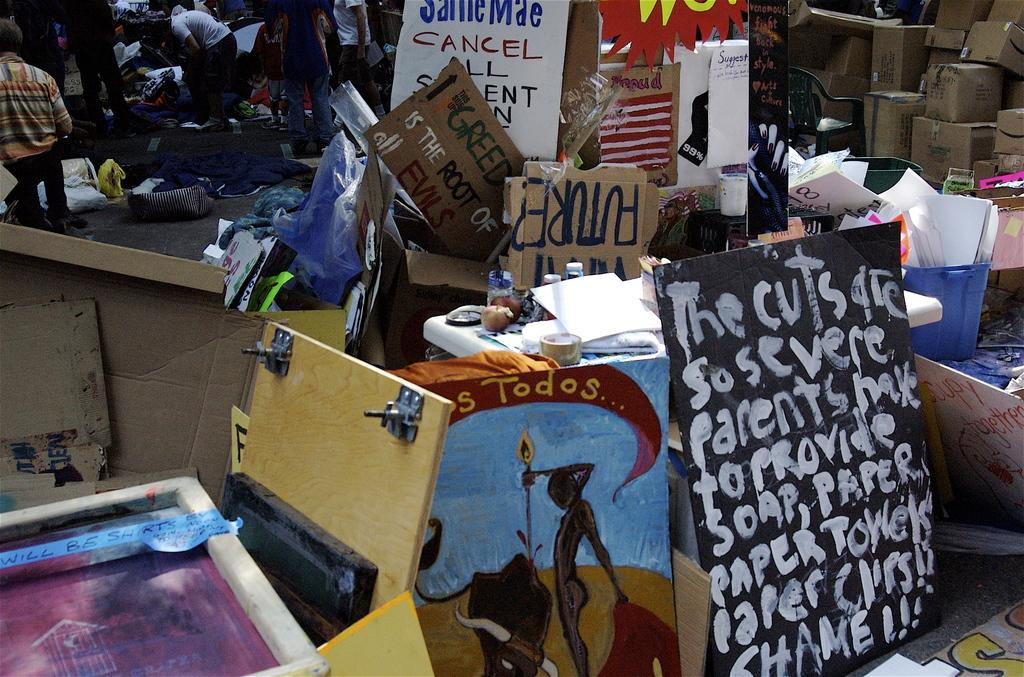Who or what can be seen in the image? There are people in the image. What objects are present in the image besides the people? There are boards, cardboard boxes, and papers visible in the image. What is covering the road in the image? There is a plastic cover on the road in the image. What can be inferred about the colors of the objects in the image? The objects mentioned are in different colors. What type of lettuce is being served on the plate in the image? There is no plate or lettuce present in the image. Can you tell me where the church is located in the image? There is no church present in the image. 